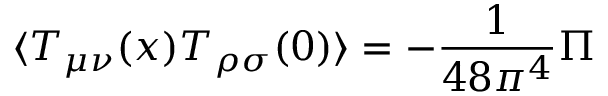Convert formula to latex. <formula><loc_0><loc_0><loc_500><loc_500>\langle T _ { \mu \nu } ( x ) T _ { \rho \sigma } ( 0 ) \rangle = - { \frac { 1 } { 4 8 \pi ^ { 4 } } } { \Pi }</formula> 